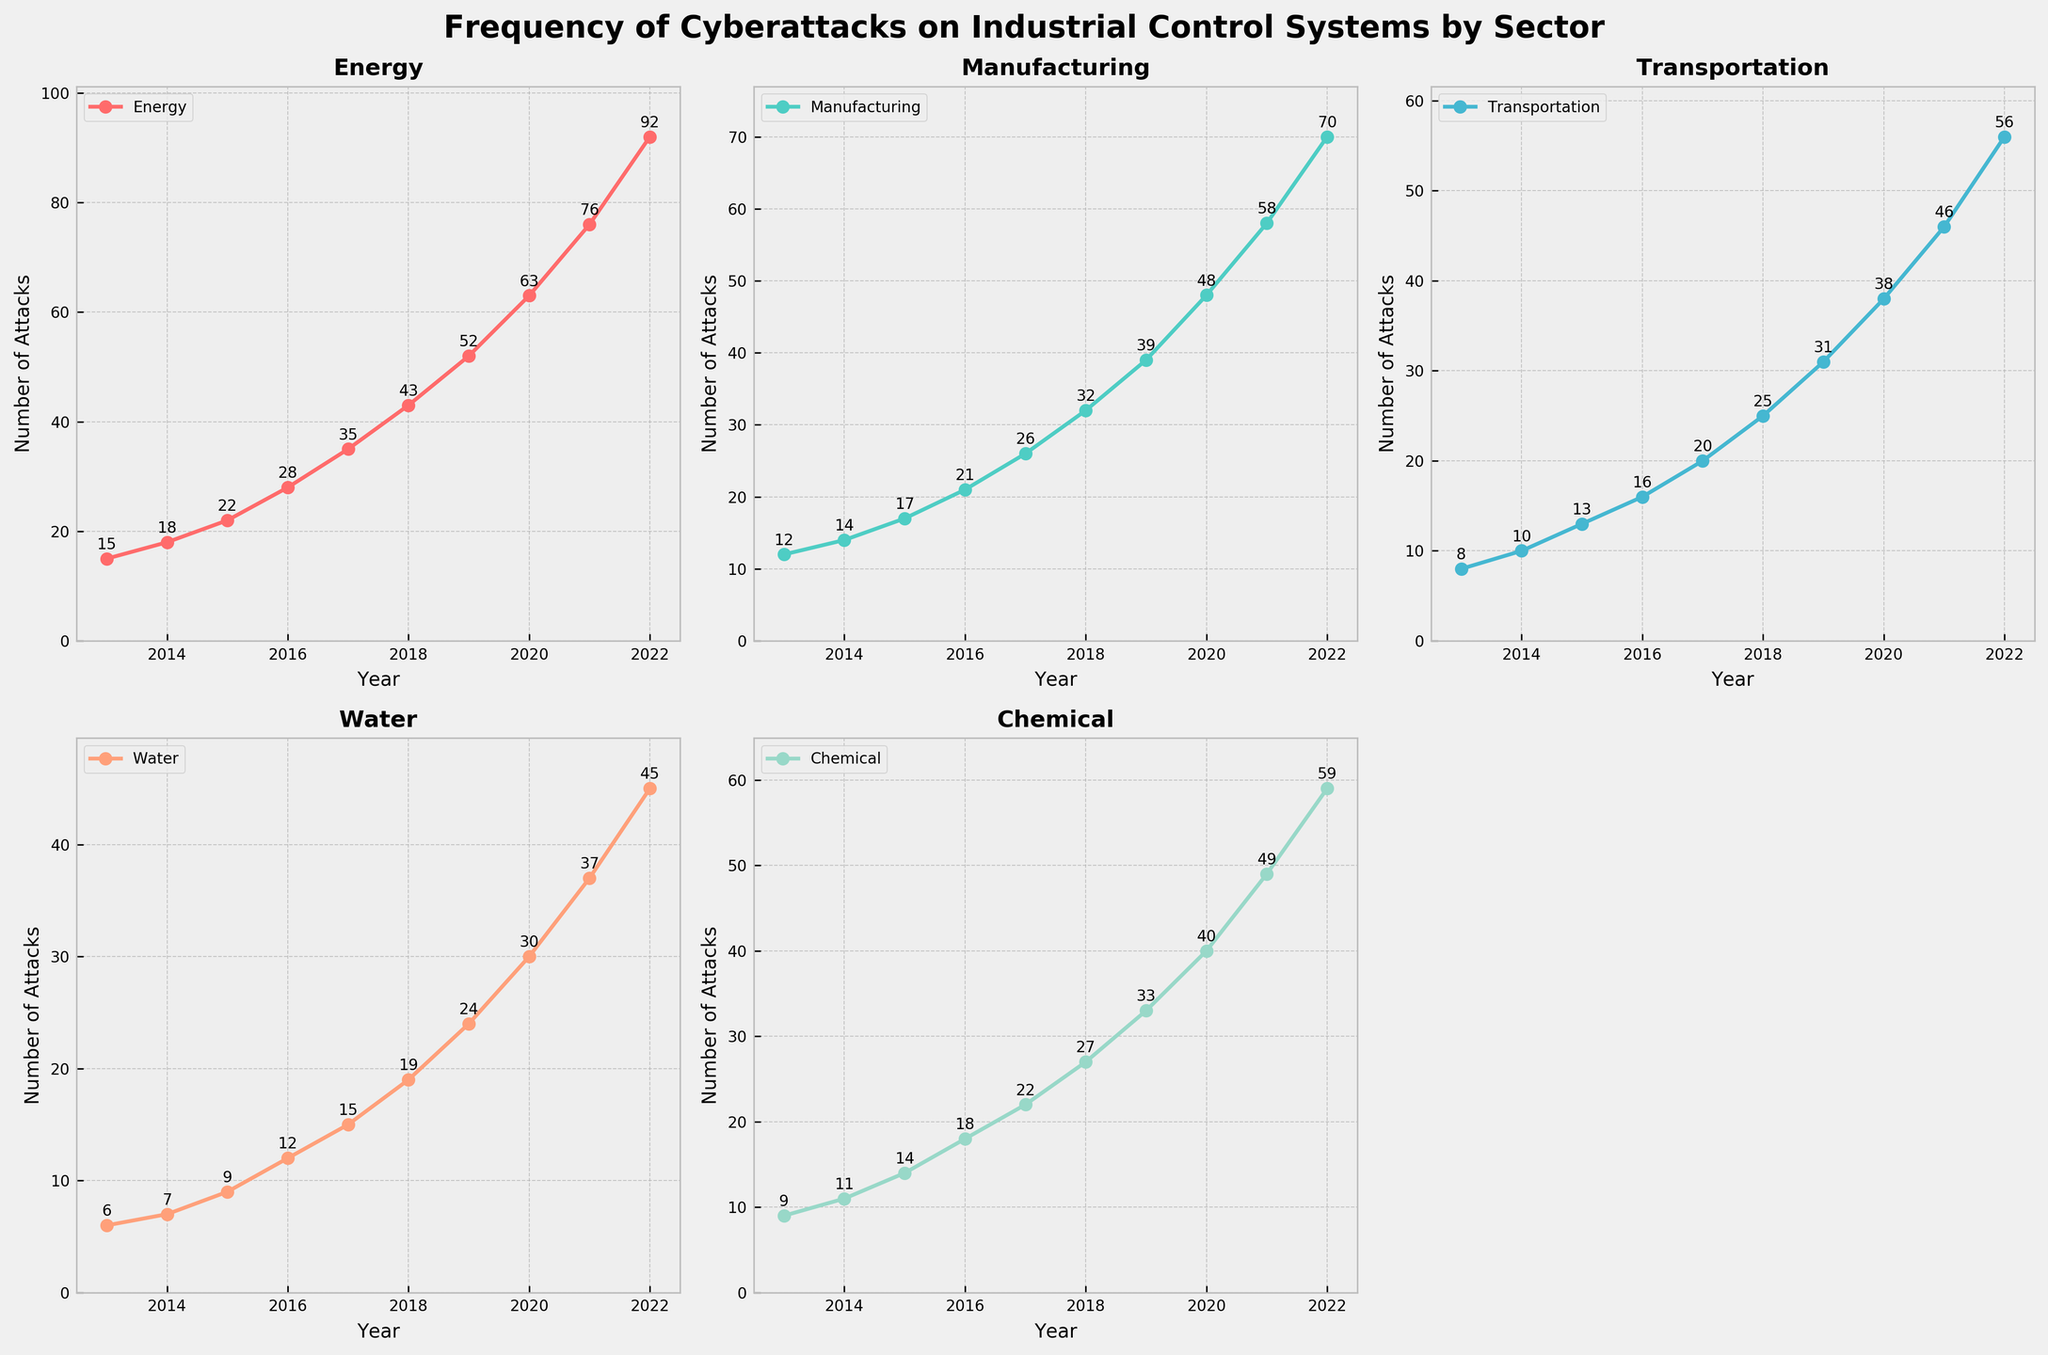What sector experienced the highest number of cyberattacks in 2022? Check each subplot for the year 2022 and find the sector with the highest Y-axis value, which is the Energy sector with 92 attacks.
Answer: Energy Which sector had the lowest increase in the number of attacks from 2013 to 2022? Calculate the difference in attacks for each sector between 2013 and 2022. Energy: 92-15=77, Manufacturing: 70-12=58, Transportation: 56-8=48, Water: 45-6=39, Chemical: 59-9=50. Water had the lowest increase with an increase of 39 attacks.
Answer: Water In which year did the Transportation sector consistently have more attacks than the Water sector? Compare the values of the Transportation and Water sectors year by year. Transportation was consistently higher from 2017 onwards.
Answer: From 2017 onwards What was the average number of attacks experienced by the Chemical sector across the decade? Sum the number of attacks in the Chemical sector from 2013 to 2022 then divide by 10: (9 + 11 + 14 + 18 + 22 + 27 + 33 + 40 + 49 + 59)/10 = 28.2
Answer: 28.2 Which year saw the most significant rise in cyberattacks in the Energy sector? Subtract the number of attacks each year from the previous year. Find the year where the increase is the highest. The differences are: 2014-2013=3, 2015-2014=4, 2016-2015=6, 2017-2016=7, 2018-2017=8, 2019-2018=9, 2020-2019=11, 2021-2020=13, 2022-2021=16. Year 2022 had the most significant rise with an increase of 16 attacks.
Answer: 2022 